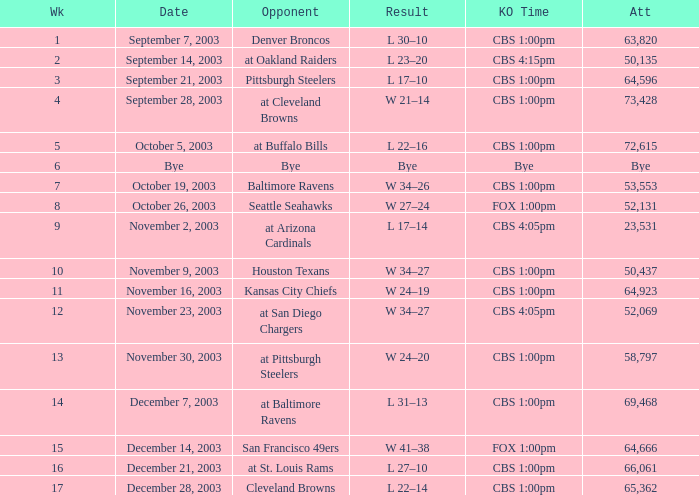What was the result of the game played on November 23, 2003? W 34–27. 